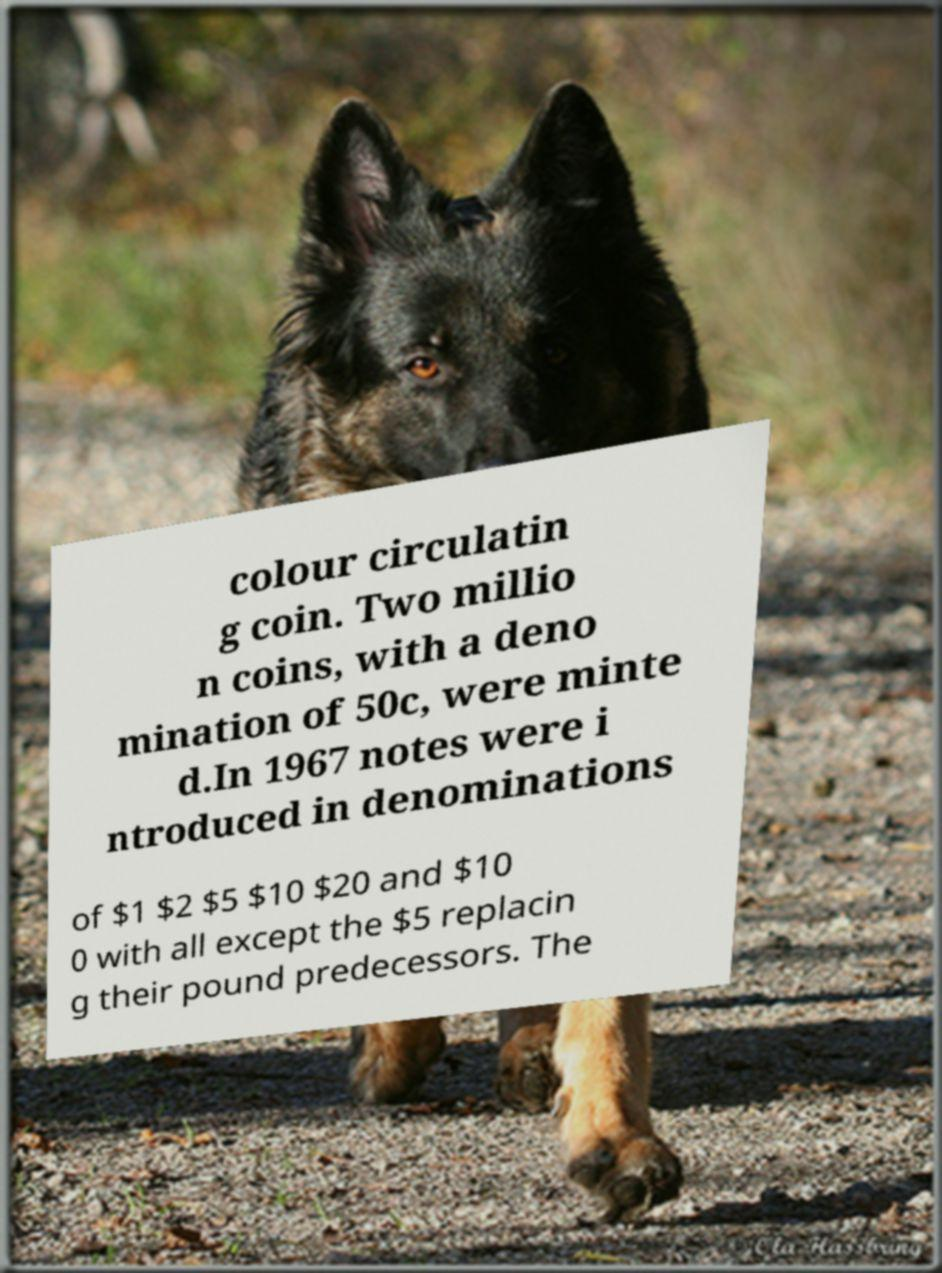What breed is the dog in the image, and what does its presence add to the photo? The dog in the image appears to be a German Shepherd. Its alert and watchful expression, coupled with its prominent position in the foreground, adds a layer of vitality and focus to the scene, contrasting with the historical information presented on the sign it is looking at. 